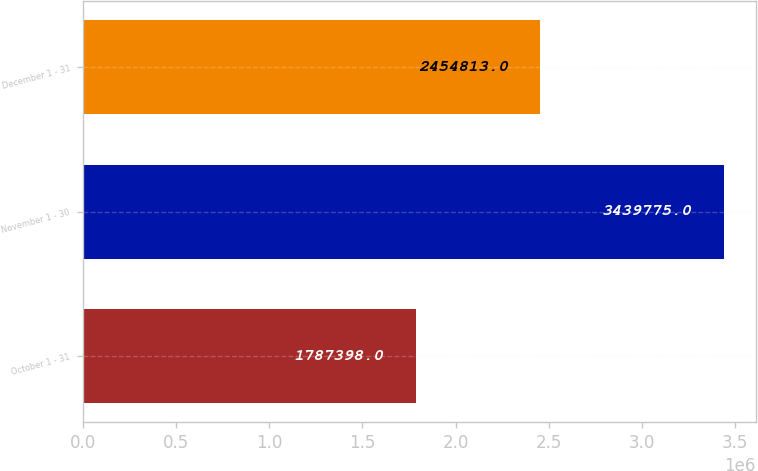<chart> <loc_0><loc_0><loc_500><loc_500><bar_chart><fcel>October 1 - 31<fcel>November 1 - 30<fcel>December 1 - 31<nl><fcel>1.7874e+06<fcel>3.43978e+06<fcel>2.45481e+06<nl></chart> 